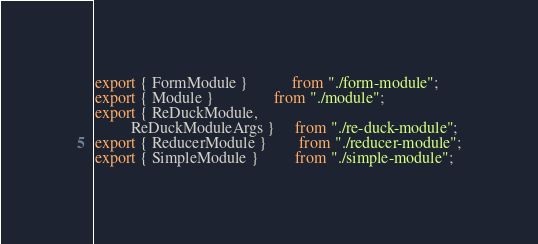<code> <loc_0><loc_0><loc_500><loc_500><_TypeScript_>export { FormModule }           from "./form-module";
export { Module }               from "./module";
export { ReDuckModule,
         ReDuckModuleArgs }     from "./re-duck-module";
export { ReducerModule }        from "./reducer-module";
export { SimpleModule }         from "./simple-module";
</code> 